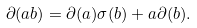<formula> <loc_0><loc_0><loc_500><loc_500>\partial ( a b ) = \partial ( a ) \sigma ( b ) + a \partial ( b ) .</formula> 